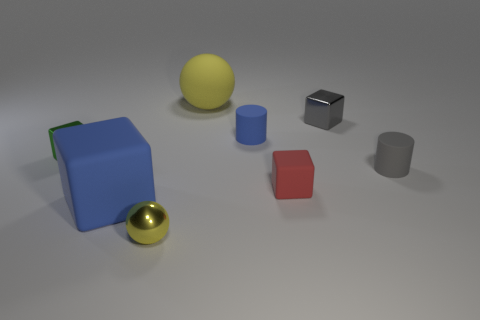What number of large blocks have the same color as the tiny ball?
Make the answer very short. 0. What size is the yellow sphere that is made of the same material as the green thing?
Offer a very short reply. Small. What is the size of the yellow ball that is behind the shiny thing to the right of the ball that is in front of the large blue object?
Offer a terse response. Large. How big is the blue rubber object in front of the green metallic block?
Offer a very short reply. Large. How many red things are tiny cubes or large rubber balls?
Offer a very short reply. 1. Is there a red matte block that has the same size as the shiny ball?
Ensure brevity in your answer.  Yes. There is a blue cylinder that is the same size as the gray shiny object; what is its material?
Provide a short and direct response. Rubber. There is a blue matte thing to the left of the large yellow sphere; is it the same size as the yellow object behind the small gray cylinder?
Provide a succinct answer. Yes. What number of objects are blue cylinders or things that are in front of the small green object?
Your response must be concise. 5. Are there any other things of the same shape as the yellow shiny object?
Make the answer very short. Yes. 